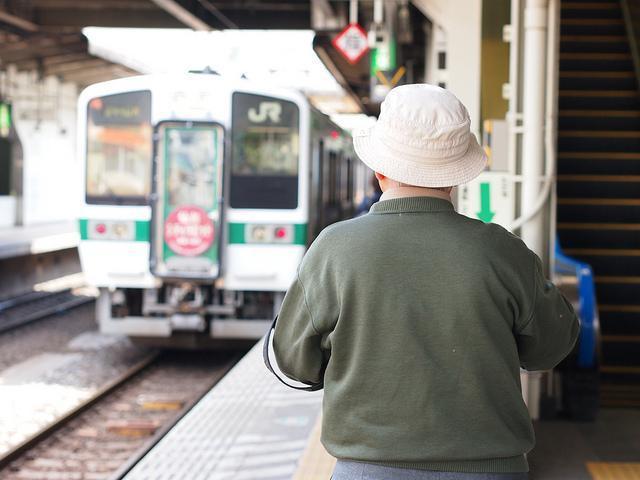How many people on motorcycles are facing this way?
Give a very brief answer. 0. 